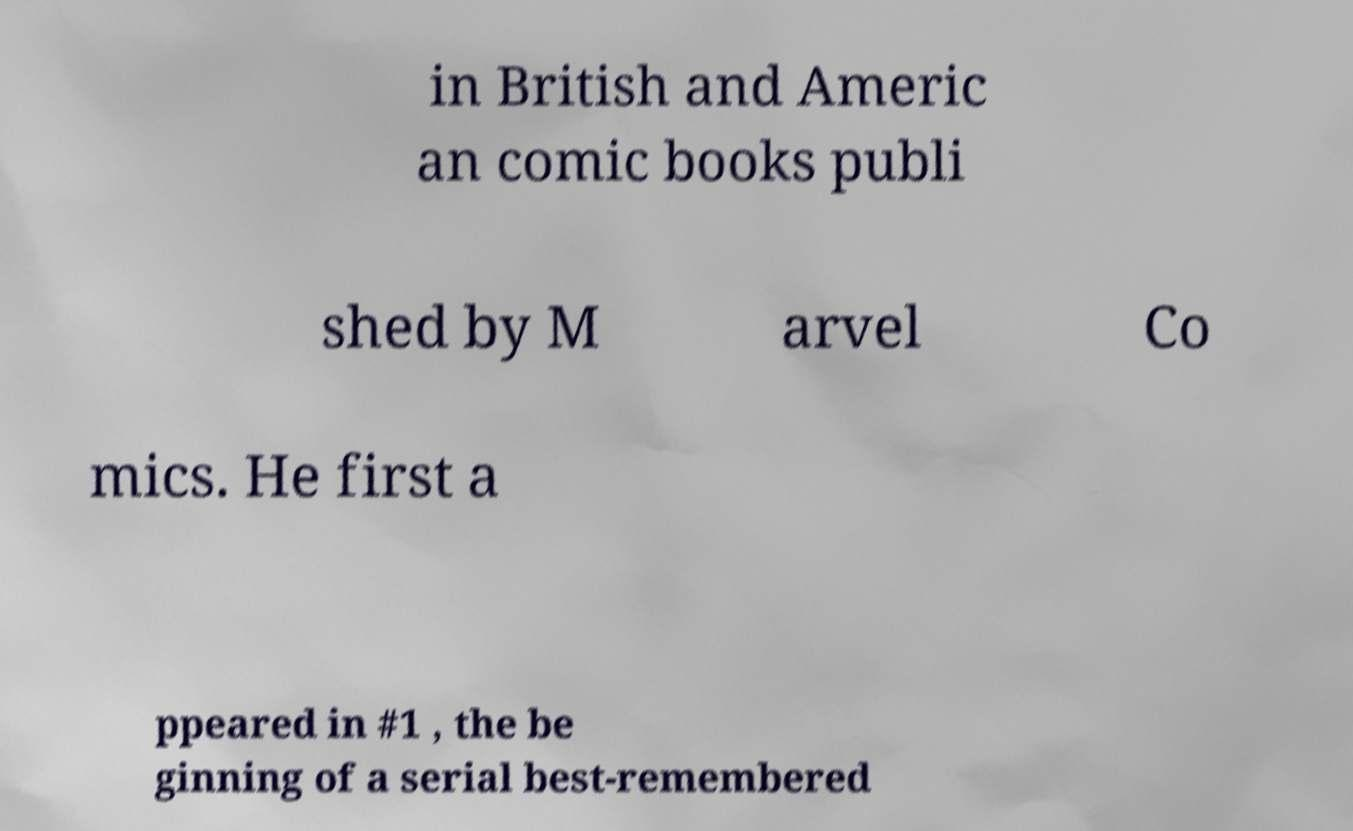I need the written content from this picture converted into text. Can you do that? in British and Americ an comic books publi shed by M arvel Co mics. He first a ppeared in #1 , the be ginning of a serial best-remembered 